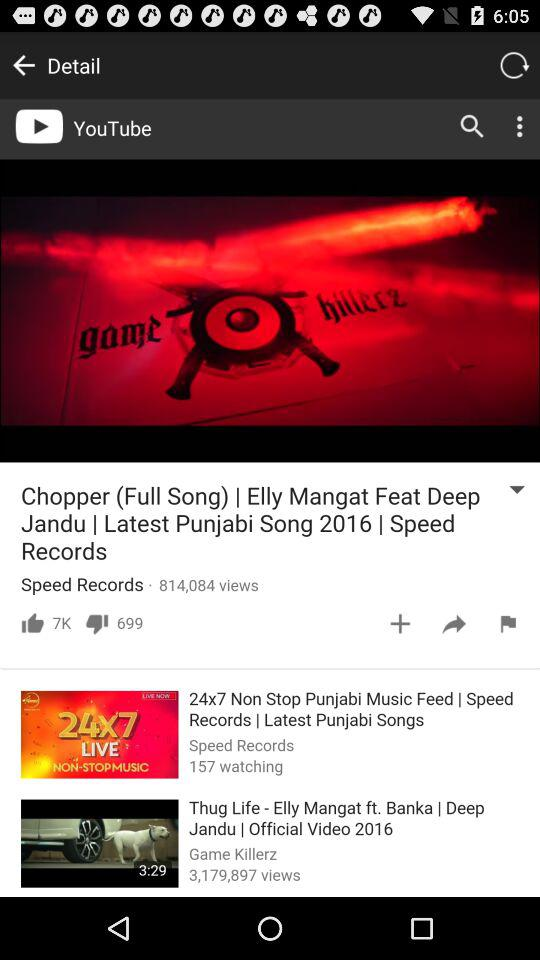What is the channel name on which "Chopper (Full Song)" is uploaded? The channel name on which "Chopper (Full Song)" is uploaded is "Speed Records". 